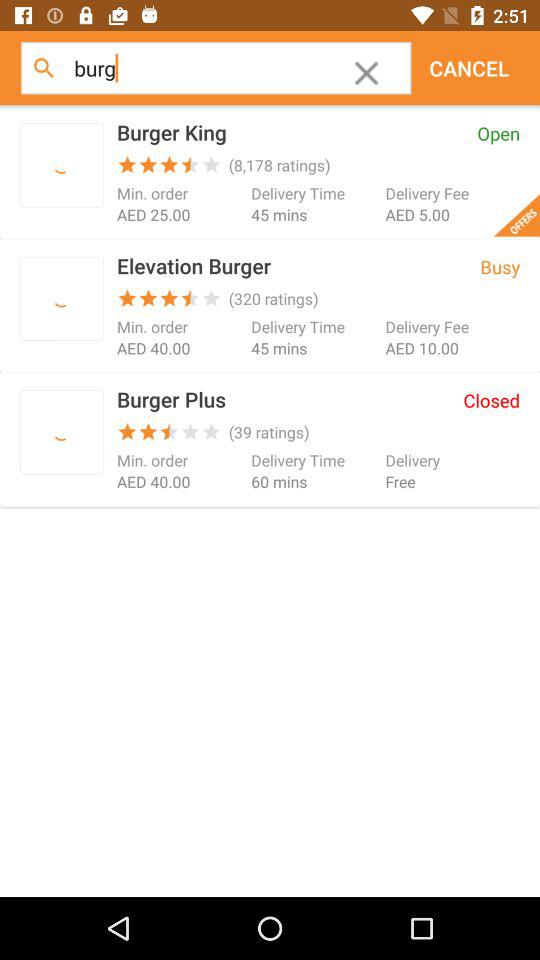Which restaurant has the lowest customer rating?
Answer the question using a single word or phrase. Burger Plus 